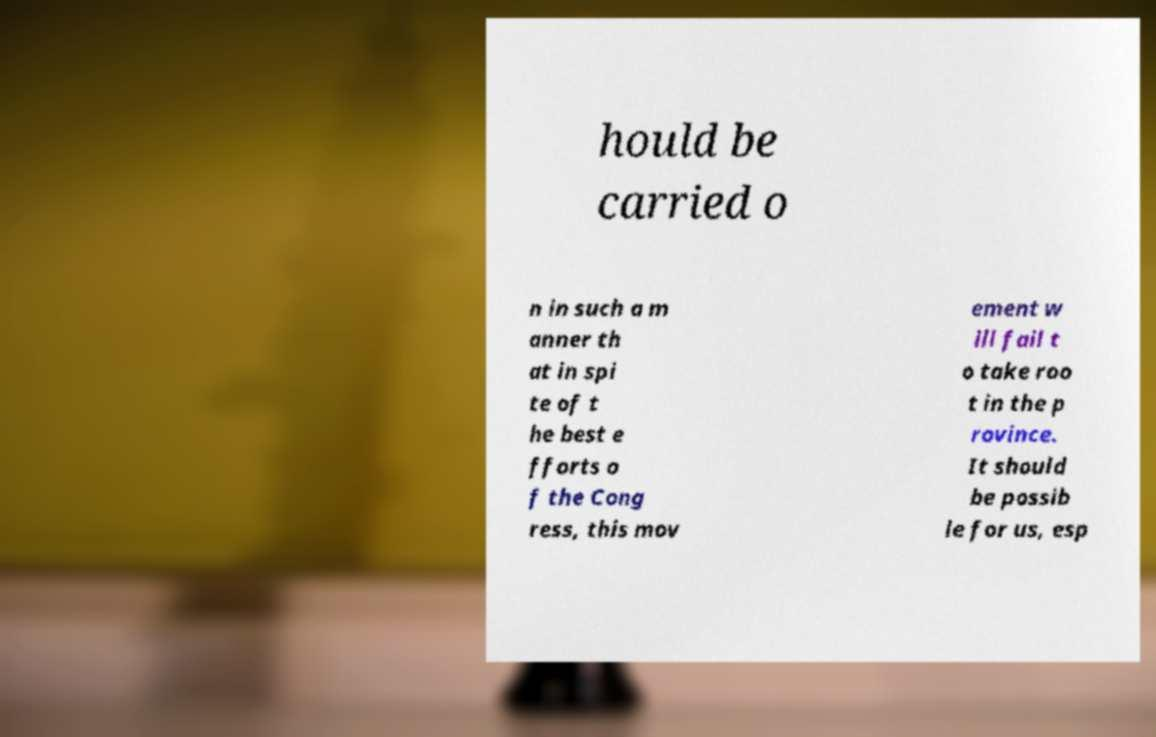Could you extract and type out the text from this image? hould be carried o n in such a m anner th at in spi te of t he best e fforts o f the Cong ress, this mov ement w ill fail t o take roo t in the p rovince. It should be possib le for us, esp 